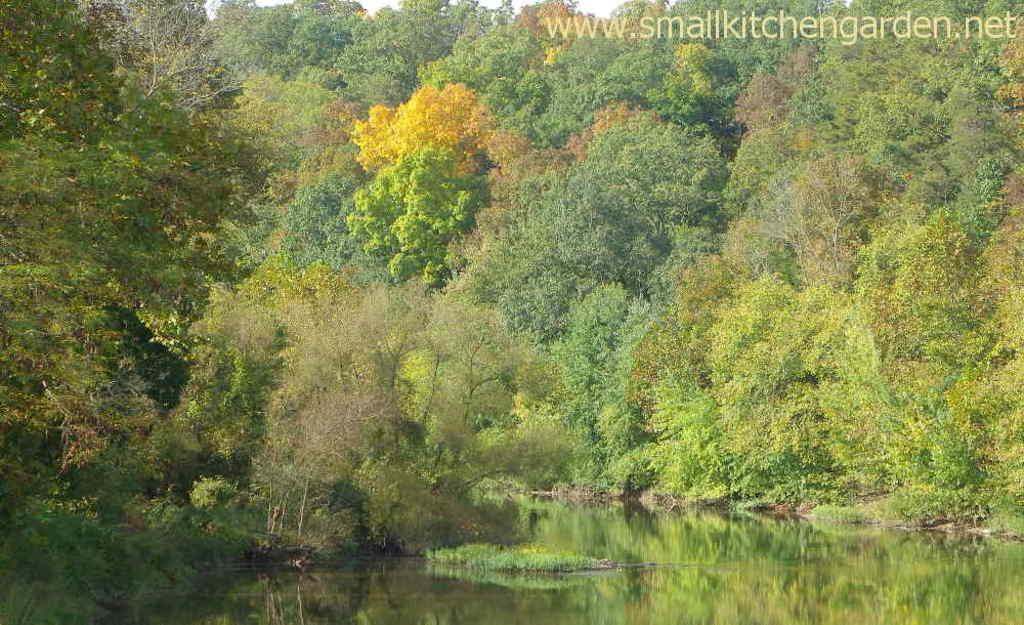What type of living organisms can be seen in the image? Plants and trees are visible in the image. What natural element is present in the image? There is water visible in the image. What part of the natural environment is visible in the image? The sky is visible in the image. How many kittens are playing on the branches of the trees in the image? There are no kittens present in the image; it features plants, trees, water, and the sky. What type of thrill can be experienced by the spiders in the image? There are no spiders present in the image, so it is not possible to determine what type of thrill they might experience. 